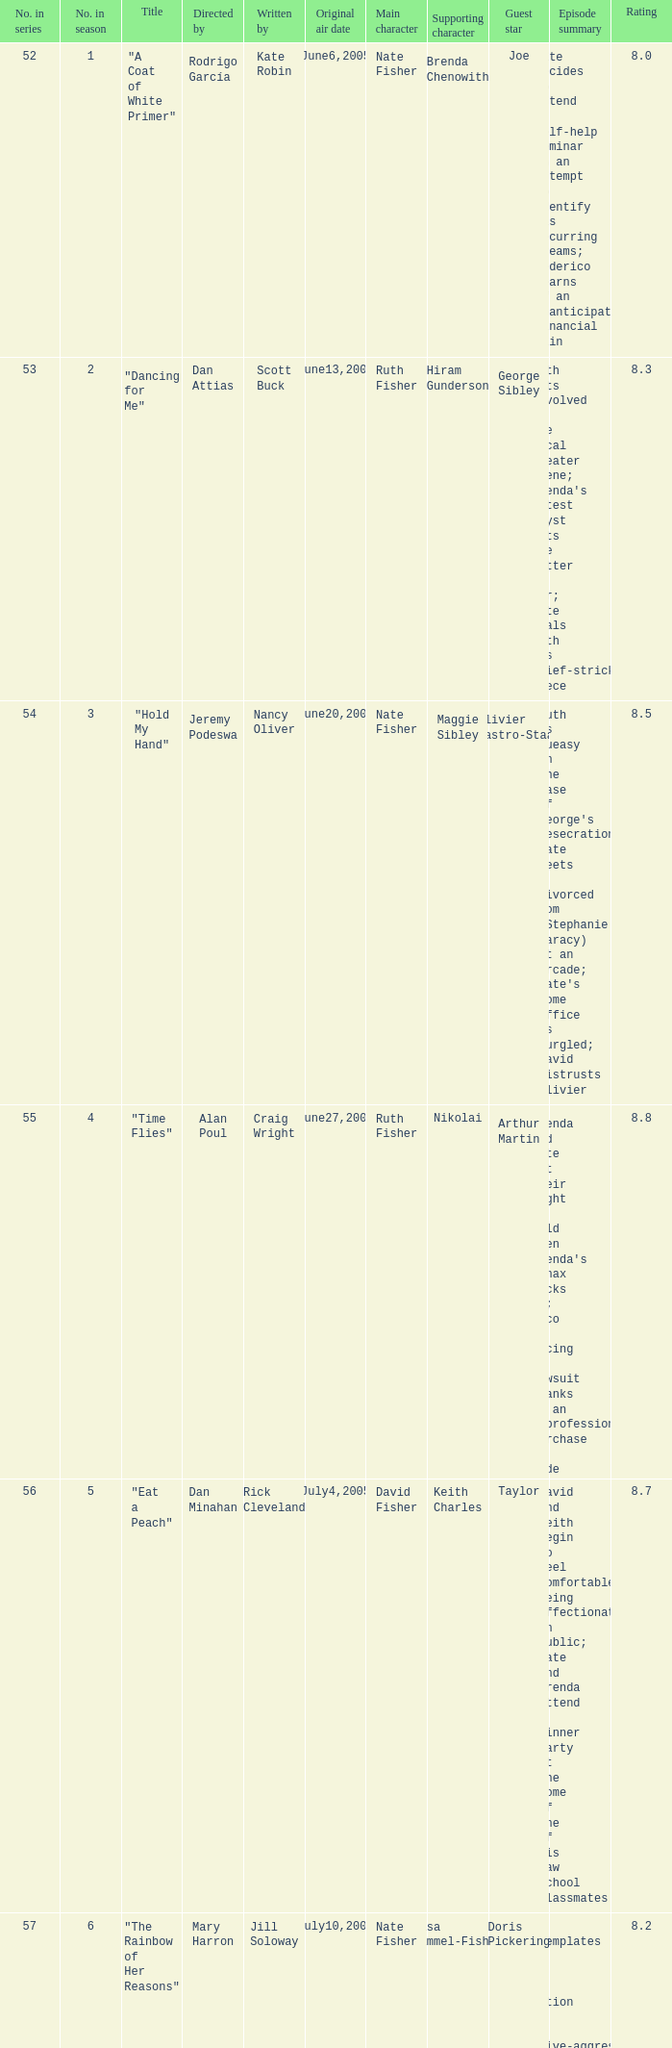What s the episode number in the season that was written by Nancy Oliver? 9.0. 